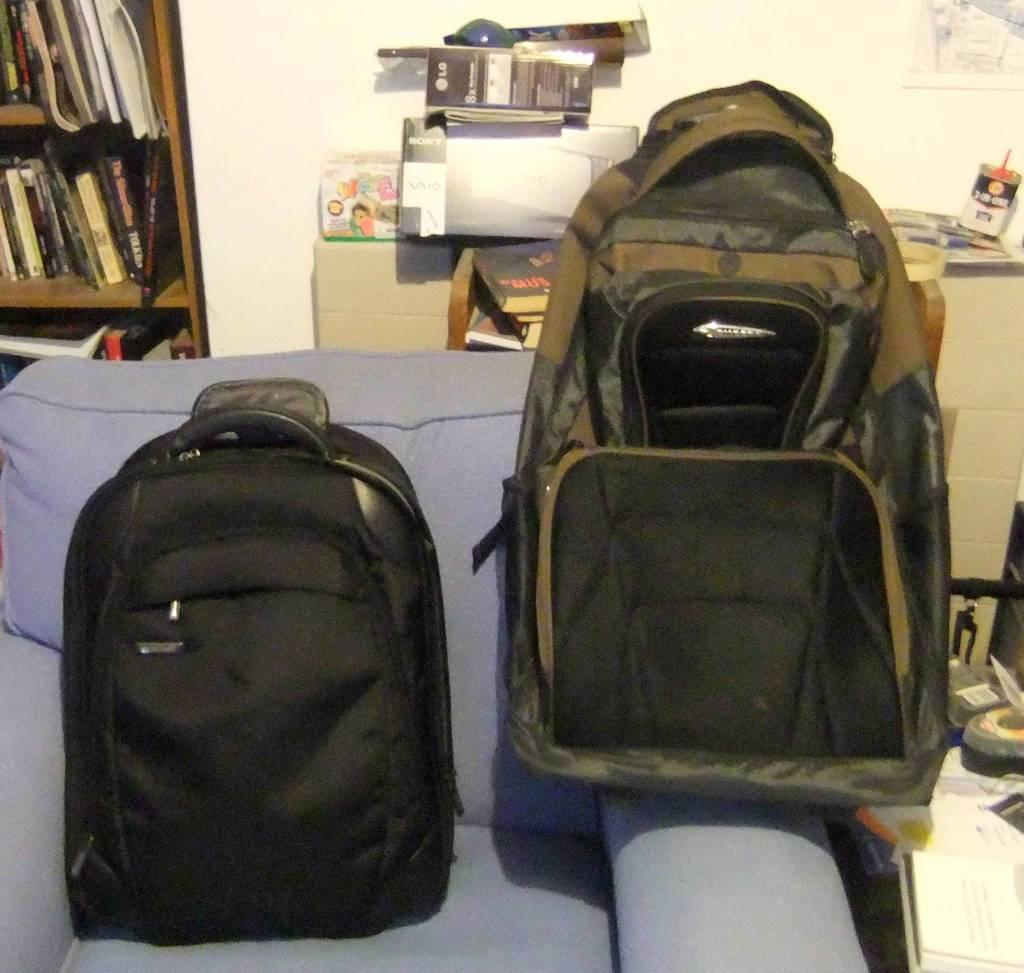What objects are on the couch in the image? There are two bags on the couch. What can be found on the rack in the image? The rack is filled with books. What items are on the table in the image? There are files, books, a box, and a container on the table. What is hanging on the wall in the image? There is a poster on the wall. What is present on the floor in the image? There are things on the floor. How many heads of the achiever can be seen in the image? There is no achiever or head present in the image. Is there a cobweb visible on the poster in the image? There is no cobweb visible in the image. 